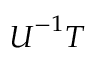<formula> <loc_0><loc_0><loc_500><loc_500>{ U } ^ { - 1 } { T }</formula> 